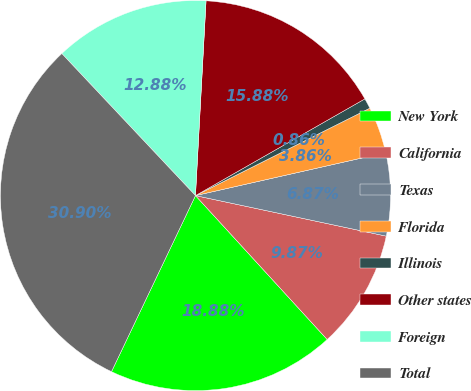<chart> <loc_0><loc_0><loc_500><loc_500><pie_chart><fcel>New York<fcel>California<fcel>Texas<fcel>Florida<fcel>Illinois<fcel>Other states<fcel>Foreign<fcel>Total<nl><fcel>18.88%<fcel>9.87%<fcel>6.87%<fcel>3.86%<fcel>0.86%<fcel>15.88%<fcel>12.88%<fcel>30.9%<nl></chart> 